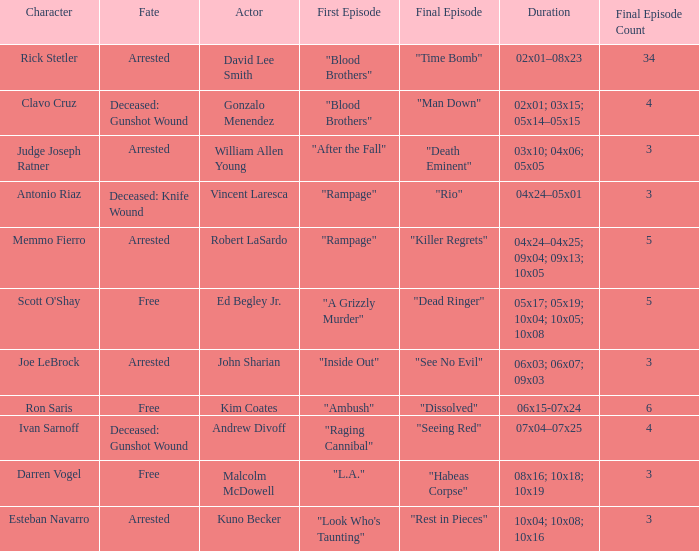Which character meets their demise through a knife wound in their fate? Antonio Riaz. 